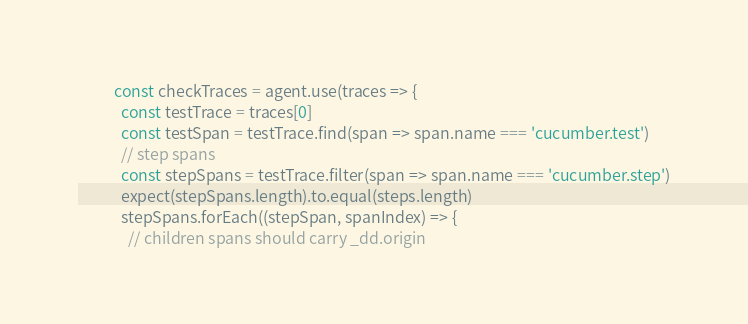Convert code to text. <code><loc_0><loc_0><loc_500><loc_500><_JavaScript_>          const checkTraces = agent.use(traces => {
            const testTrace = traces[0]
            const testSpan = testTrace.find(span => span.name === 'cucumber.test')
            // step spans
            const stepSpans = testTrace.filter(span => span.name === 'cucumber.step')
            expect(stepSpans.length).to.equal(steps.length)
            stepSpans.forEach((stepSpan, spanIndex) => {
              // children spans should carry _dd.origin</code> 